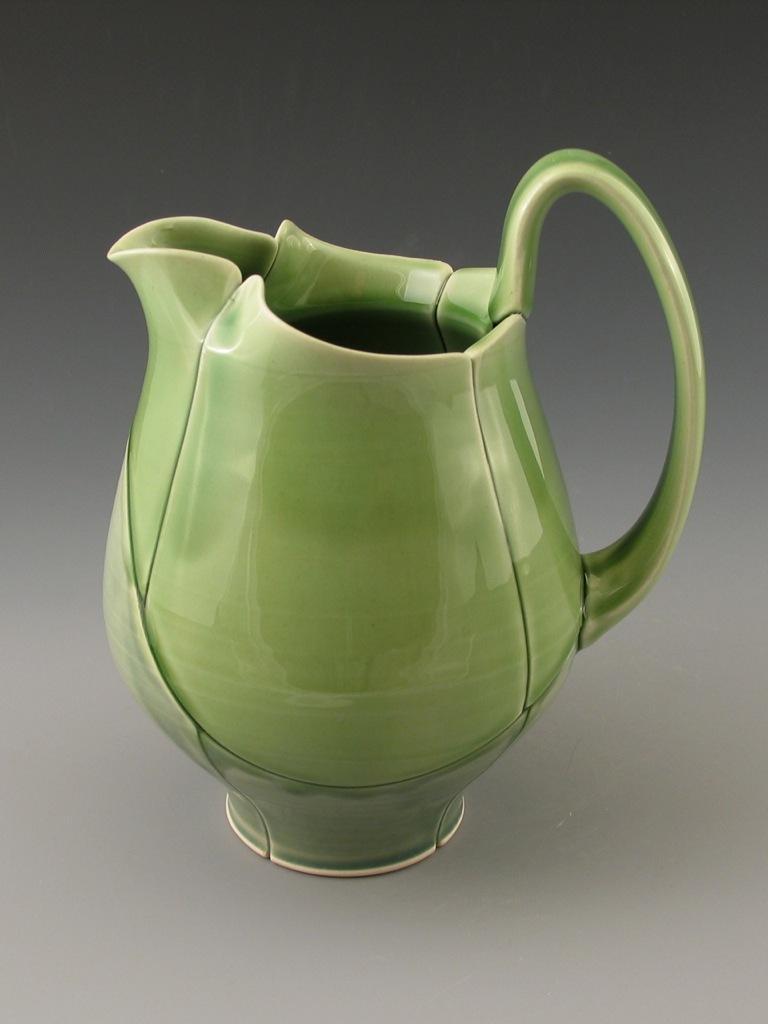How would you summarize this image in a sentence or two? In this picture I can see a pottery pitcher on an object. 